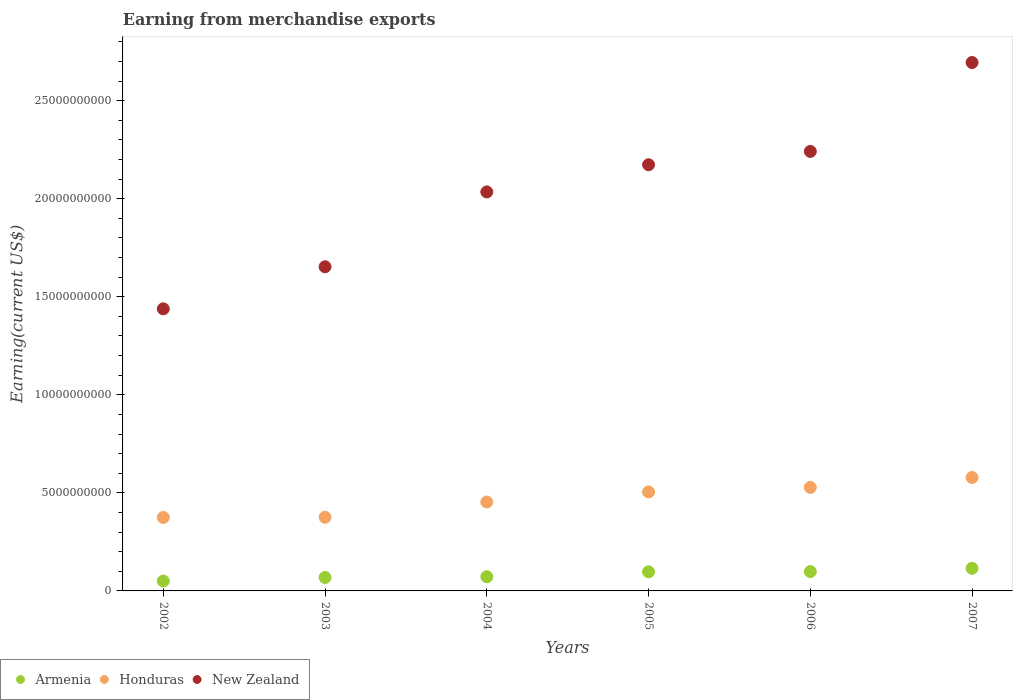Is the number of dotlines equal to the number of legend labels?
Provide a succinct answer. Yes. What is the amount earned from merchandise exports in Honduras in 2007?
Your answer should be very brief. 5.78e+09. Across all years, what is the maximum amount earned from merchandise exports in Honduras?
Ensure brevity in your answer.  5.78e+09. Across all years, what is the minimum amount earned from merchandise exports in New Zealand?
Your answer should be compact. 1.44e+1. What is the total amount earned from merchandise exports in Honduras in the graph?
Provide a succinct answer. 2.81e+1. What is the difference between the amount earned from merchandise exports in Honduras in 2003 and that in 2005?
Your answer should be very brief. -1.29e+09. What is the difference between the amount earned from merchandise exports in New Zealand in 2006 and the amount earned from merchandise exports in Honduras in 2005?
Your answer should be compact. 1.74e+1. What is the average amount earned from merchandise exports in Honduras per year?
Provide a short and direct response. 4.69e+09. In the year 2002, what is the difference between the amount earned from merchandise exports in New Zealand and amount earned from merchandise exports in Armenia?
Offer a very short reply. 1.39e+1. In how many years, is the amount earned from merchandise exports in Honduras greater than 21000000000 US$?
Provide a succinct answer. 0. What is the ratio of the amount earned from merchandise exports in Armenia in 2002 to that in 2003?
Make the answer very short. 0.74. What is the difference between the highest and the second highest amount earned from merchandise exports in Honduras?
Give a very brief answer. 5.07e+08. What is the difference between the highest and the lowest amount earned from merchandise exports in New Zealand?
Your response must be concise. 1.26e+1. Is the sum of the amount earned from merchandise exports in Honduras in 2002 and 2006 greater than the maximum amount earned from merchandise exports in Armenia across all years?
Your response must be concise. Yes. Is the amount earned from merchandise exports in New Zealand strictly greater than the amount earned from merchandise exports in Honduras over the years?
Keep it short and to the point. Yes. How many dotlines are there?
Your answer should be very brief. 3. What is the difference between two consecutive major ticks on the Y-axis?
Ensure brevity in your answer.  5.00e+09. Are the values on the major ticks of Y-axis written in scientific E-notation?
Your response must be concise. No. Does the graph contain any zero values?
Your answer should be compact. No. What is the title of the graph?
Keep it short and to the point. Earning from merchandise exports. Does "Europe(all income levels)" appear as one of the legend labels in the graph?
Offer a terse response. No. What is the label or title of the Y-axis?
Your answer should be compact. Earning(current US$). What is the Earning(current US$) of Armenia in 2002?
Offer a terse response. 5.05e+08. What is the Earning(current US$) in Honduras in 2002?
Your response must be concise. 3.74e+09. What is the Earning(current US$) in New Zealand in 2002?
Ensure brevity in your answer.  1.44e+1. What is the Earning(current US$) of Armenia in 2003?
Your answer should be compact. 6.86e+08. What is the Earning(current US$) in Honduras in 2003?
Your answer should be very brief. 3.75e+09. What is the Earning(current US$) of New Zealand in 2003?
Your answer should be very brief. 1.65e+1. What is the Earning(current US$) of Armenia in 2004?
Give a very brief answer. 7.23e+08. What is the Earning(current US$) of Honduras in 2004?
Your answer should be very brief. 4.53e+09. What is the Earning(current US$) of New Zealand in 2004?
Provide a succinct answer. 2.03e+1. What is the Earning(current US$) in Armenia in 2005?
Keep it short and to the point. 9.74e+08. What is the Earning(current US$) of Honduras in 2005?
Your response must be concise. 5.05e+09. What is the Earning(current US$) in New Zealand in 2005?
Keep it short and to the point. 2.17e+1. What is the Earning(current US$) of Armenia in 2006?
Your answer should be compact. 9.85e+08. What is the Earning(current US$) in Honduras in 2006?
Your answer should be compact. 5.28e+09. What is the Earning(current US$) of New Zealand in 2006?
Offer a terse response. 2.24e+1. What is the Earning(current US$) of Armenia in 2007?
Make the answer very short. 1.15e+09. What is the Earning(current US$) of Honduras in 2007?
Keep it short and to the point. 5.78e+09. What is the Earning(current US$) in New Zealand in 2007?
Your response must be concise. 2.69e+1. Across all years, what is the maximum Earning(current US$) in Armenia?
Make the answer very short. 1.15e+09. Across all years, what is the maximum Earning(current US$) of Honduras?
Provide a succinct answer. 5.78e+09. Across all years, what is the maximum Earning(current US$) of New Zealand?
Your response must be concise. 2.69e+1. Across all years, what is the minimum Earning(current US$) in Armenia?
Ensure brevity in your answer.  5.05e+08. Across all years, what is the minimum Earning(current US$) of Honduras?
Provide a succinct answer. 3.74e+09. Across all years, what is the minimum Earning(current US$) in New Zealand?
Give a very brief answer. 1.44e+1. What is the total Earning(current US$) in Armenia in the graph?
Keep it short and to the point. 5.02e+09. What is the total Earning(current US$) in Honduras in the graph?
Offer a terse response. 2.81e+1. What is the total Earning(current US$) of New Zealand in the graph?
Provide a short and direct response. 1.22e+11. What is the difference between the Earning(current US$) in Armenia in 2002 and that in 2003?
Your answer should be compact. -1.80e+08. What is the difference between the Earning(current US$) of Honduras in 2002 and that in 2003?
Your answer should be very brief. -9.14e+06. What is the difference between the Earning(current US$) in New Zealand in 2002 and that in 2003?
Your answer should be very brief. -2.14e+09. What is the difference between the Earning(current US$) of Armenia in 2002 and that in 2004?
Offer a very short reply. -2.18e+08. What is the difference between the Earning(current US$) of Honduras in 2002 and that in 2004?
Give a very brief answer. -7.89e+08. What is the difference between the Earning(current US$) in New Zealand in 2002 and that in 2004?
Provide a short and direct response. -5.96e+09. What is the difference between the Earning(current US$) of Armenia in 2002 and that in 2005?
Your response must be concise. -4.69e+08. What is the difference between the Earning(current US$) in Honduras in 2002 and that in 2005?
Provide a short and direct response. -1.30e+09. What is the difference between the Earning(current US$) of New Zealand in 2002 and that in 2005?
Offer a terse response. -7.35e+09. What is the difference between the Earning(current US$) in Armenia in 2002 and that in 2006?
Make the answer very short. -4.80e+08. What is the difference between the Earning(current US$) of Honduras in 2002 and that in 2006?
Keep it short and to the point. -1.53e+09. What is the difference between the Earning(current US$) of New Zealand in 2002 and that in 2006?
Offer a very short reply. -8.03e+09. What is the difference between the Earning(current US$) in Armenia in 2002 and that in 2007?
Keep it short and to the point. -6.47e+08. What is the difference between the Earning(current US$) in Honduras in 2002 and that in 2007?
Ensure brevity in your answer.  -2.04e+09. What is the difference between the Earning(current US$) of New Zealand in 2002 and that in 2007?
Give a very brief answer. -1.26e+1. What is the difference between the Earning(current US$) in Armenia in 2003 and that in 2004?
Ensure brevity in your answer.  -3.73e+07. What is the difference between the Earning(current US$) in Honduras in 2003 and that in 2004?
Your answer should be compact. -7.80e+08. What is the difference between the Earning(current US$) in New Zealand in 2003 and that in 2004?
Your answer should be very brief. -3.82e+09. What is the difference between the Earning(current US$) of Armenia in 2003 and that in 2005?
Offer a terse response. -2.88e+08. What is the difference between the Earning(current US$) in Honduras in 2003 and that in 2005?
Your answer should be compact. -1.29e+09. What is the difference between the Earning(current US$) of New Zealand in 2003 and that in 2005?
Give a very brief answer. -5.20e+09. What is the difference between the Earning(current US$) in Armenia in 2003 and that in 2006?
Make the answer very short. -3.00e+08. What is the difference between the Earning(current US$) in Honduras in 2003 and that in 2006?
Ensure brevity in your answer.  -1.52e+09. What is the difference between the Earning(current US$) in New Zealand in 2003 and that in 2006?
Provide a succinct answer. -5.88e+09. What is the difference between the Earning(current US$) in Armenia in 2003 and that in 2007?
Your answer should be compact. -4.67e+08. What is the difference between the Earning(current US$) of Honduras in 2003 and that in 2007?
Make the answer very short. -2.03e+09. What is the difference between the Earning(current US$) of New Zealand in 2003 and that in 2007?
Offer a very short reply. -1.04e+1. What is the difference between the Earning(current US$) in Armenia in 2004 and that in 2005?
Offer a very short reply. -2.51e+08. What is the difference between the Earning(current US$) in Honduras in 2004 and that in 2005?
Offer a very short reply. -5.14e+08. What is the difference between the Earning(current US$) in New Zealand in 2004 and that in 2005?
Provide a short and direct response. -1.39e+09. What is the difference between the Earning(current US$) in Armenia in 2004 and that in 2006?
Give a very brief answer. -2.62e+08. What is the difference between the Earning(current US$) in Honduras in 2004 and that in 2006?
Ensure brevity in your answer.  -7.43e+08. What is the difference between the Earning(current US$) of New Zealand in 2004 and that in 2006?
Your answer should be very brief. -2.07e+09. What is the difference between the Earning(current US$) in Armenia in 2004 and that in 2007?
Your answer should be very brief. -4.29e+08. What is the difference between the Earning(current US$) in Honduras in 2004 and that in 2007?
Your answer should be very brief. -1.25e+09. What is the difference between the Earning(current US$) of New Zealand in 2004 and that in 2007?
Your answer should be very brief. -6.60e+09. What is the difference between the Earning(current US$) of Armenia in 2005 and that in 2006?
Provide a short and direct response. -1.12e+07. What is the difference between the Earning(current US$) of Honduras in 2005 and that in 2006?
Ensure brevity in your answer.  -2.29e+08. What is the difference between the Earning(current US$) in New Zealand in 2005 and that in 2006?
Offer a terse response. -6.79e+08. What is the difference between the Earning(current US$) in Armenia in 2005 and that in 2007?
Give a very brief answer. -1.78e+08. What is the difference between the Earning(current US$) of Honduras in 2005 and that in 2007?
Provide a short and direct response. -7.36e+08. What is the difference between the Earning(current US$) of New Zealand in 2005 and that in 2007?
Give a very brief answer. -5.21e+09. What is the difference between the Earning(current US$) of Armenia in 2006 and that in 2007?
Your answer should be very brief. -1.67e+08. What is the difference between the Earning(current US$) of Honduras in 2006 and that in 2007?
Offer a very short reply. -5.07e+08. What is the difference between the Earning(current US$) of New Zealand in 2006 and that in 2007?
Your answer should be compact. -4.53e+09. What is the difference between the Earning(current US$) in Armenia in 2002 and the Earning(current US$) in Honduras in 2003?
Your response must be concise. -3.25e+09. What is the difference between the Earning(current US$) in Armenia in 2002 and the Earning(current US$) in New Zealand in 2003?
Ensure brevity in your answer.  -1.60e+1. What is the difference between the Earning(current US$) of Honduras in 2002 and the Earning(current US$) of New Zealand in 2003?
Offer a terse response. -1.28e+1. What is the difference between the Earning(current US$) in Armenia in 2002 and the Earning(current US$) in Honduras in 2004?
Your answer should be compact. -4.03e+09. What is the difference between the Earning(current US$) in Armenia in 2002 and the Earning(current US$) in New Zealand in 2004?
Make the answer very short. -1.98e+1. What is the difference between the Earning(current US$) of Honduras in 2002 and the Earning(current US$) of New Zealand in 2004?
Your answer should be compact. -1.66e+1. What is the difference between the Earning(current US$) in Armenia in 2002 and the Earning(current US$) in Honduras in 2005?
Keep it short and to the point. -4.54e+09. What is the difference between the Earning(current US$) in Armenia in 2002 and the Earning(current US$) in New Zealand in 2005?
Provide a succinct answer. -2.12e+1. What is the difference between the Earning(current US$) of Honduras in 2002 and the Earning(current US$) of New Zealand in 2005?
Offer a very short reply. -1.80e+1. What is the difference between the Earning(current US$) in Armenia in 2002 and the Earning(current US$) in Honduras in 2006?
Provide a short and direct response. -4.77e+09. What is the difference between the Earning(current US$) in Armenia in 2002 and the Earning(current US$) in New Zealand in 2006?
Offer a very short reply. -2.19e+1. What is the difference between the Earning(current US$) of Honduras in 2002 and the Earning(current US$) of New Zealand in 2006?
Provide a succinct answer. -1.87e+1. What is the difference between the Earning(current US$) in Armenia in 2002 and the Earning(current US$) in Honduras in 2007?
Your answer should be compact. -5.28e+09. What is the difference between the Earning(current US$) of Armenia in 2002 and the Earning(current US$) of New Zealand in 2007?
Your answer should be very brief. -2.64e+1. What is the difference between the Earning(current US$) in Honduras in 2002 and the Earning(current US$) in New Zealand in 2007?
Your response must be concise. -2.32e+1. What is the difference between the Earning(current US$) in Armenia in 2003 and the Earning(current US$) in Honduras in 2004?
Your answer should be very brief. -3.85e+09. What is the difference between the Earning(current US$) of Armenia in 2003 and the Earning(current US$) of New Zealand in 2004?
Keep it short and to the point. -1.97e+1. What is the difference between the Earning(current US$) in Honduras in 2003 and the Earning(current US$) in New Zealand in 2004?
Your response must be concise. -1.66e+1. What is the difference between the Earning(current US$) in Armenia in 2003 and the Earning(current US$) in Honduras in 2005?
Keep it short and to the point. -4.36e+09. What is the difference between the Earning(current US$) of Armenia in 2003 and the Earning(current US$) of New Zealand in 2005?
Your answer should be very brief. -2.10e+1. What is the difference between the Earning(current US$) of Honduras in 2003 and the Earning(current US$) of New Zealand in 2005?
Your answer should be very brief. -1.80e+1. What is the difference between the Earning(current US$) in Armenia in 2003 and the Earning(current US$) in Honduras in 2006?
Your answer should be compact. -4.59e+09. What is the difference between the Earning(current US$) of Armenia in 2003 and the Earning(current US$) of New Zealand in 2006?
Your response must be concise. -2.17e+1. What is the difference between the Earning(current US$) in Honduras in 2003 and the Earning(current US$) in New Zealand in 2006?
Your answer should be compact. -1.87e+1. What is the difference between the Earning(current US$) in Armenia in 2003 and the Earning(current US$) in Honduras in 2007?
Provide a succinct answer. -5.10e+09. What is the difference between the Earning(current US$) in Armenia in 2003 and the Earning(current US$) in New Zealand in 2007?
Your response must be concise. -2.63e+1. What is the difference between the Earning(current US$) of Honduras in 2003 and the Earning(current US$) of New Zealand in 2007?
Your answer should be very brief. -2.32e+1. What is the difference between the Earning(current US$) in Armenia in 2004 and the Earning(current US$) in Honduras in 2005?
Your response must be concise. -4.33e+09. What is the difference between the Earning(current US$) of Armenia in 2004 and the Earning(current US$) of New Zealand in 2005?
Your answer should be very brief. -2.10e+1. What is the difference between the Earning(current US$) in Honduras in 2004 and the Earning(current US$) in New Zealand in 2005?
Ensure brevity in your answer.  -1.72e+1. What is the difference between the Earning(current US$) of Armenia in 2004 and the Earning(current US$) of Honduras in 2006?
Ensure brevity in your answer.  -4.55e+09. What is the difference between the Earning(current US$) in Armenia in 2004 and the Earning(current US$) in New Zealand in 2006?
Your response must be concise. -2.17e+1. What is the difference between the Earning(current US$) in Honduras in 2004 and the Earning(current US$) in New Zealand in 2006?
Ensure brevity in your answer.  -1.79e+1. What is the difference between the Earning(current US$) of Armenia in 2004 and the Earning(current US$) of Honduras in 2007?
Your answer should be compact. -5.06e+09. What is the difference between the Earning(current US$) of Armenia in 2004 and the Earning(current US$) of New Zealand in 2007?
Provide a short and direct response. -2.62e+1. What is the difference between the Earning(current US$) in Honduras in 2004 and the Earning(current US$) in New Zealand in 2007?
Give a very brief answer. -2.24e+1. What is the difference between the Earning(current US$) in Armenia in 2005 and the Earning(current US$) in Honduras in 2006?
Make the answer very short. -4.30e+09. What is the difference between the Earning(current US$) in Armenia in 2005 and the Earning(current US$) in New Zealand in 2006?
Your answer should be very brief. -2.14e+1. What is the difference between the Earning(current US$) of Honduras in 2005 and the Earning(current US$) of New Zealand in 2006?
Provide a succinct answer. -1.74e+1. What is the difference between the Earning(current US$) in Armenia in 2005 and the Earning(current US$) in Honduras in 2007?
Keep it short and to the point. -4.81e+09. What is the difference between the Earning(current US$) of Armenia in 2005 and the Earning(current US$) of New Zealand in 2007?
Your answer should be very brief. -2.60e+1. What is the difference between the Earning(current US$) in Honduras in 2005 and the Earning(current US$) in New Zealand in 2007?
Your answer should be very brief. -2.19e+1. What is the difference between the Earning(current US$) in Armenia in 2006 and the Earning(current US$) in Honduras in 2007?
Provide a succinct answer. -4.80e+09. What is the difference between the Earning(current US$) of Armenia in 2006 and the Earning(current US$) of New Zealand in 2007?
Offer a very short reply. -2.60e+1. What is the difference between the Earning(current US$) of Honduras in 2006 and the Earning(current US$) of New Zealand in 2007?
Your response must be concise. -2.17e+1. What is the average Earning(current US$) in Armenia per year?
Your answer should be compact. 8.37e+08. What is the average Earning(current US$) of Honduras per year?
Provide a short and direct response. 4.69e+09. What is the average Earning(current US$) of New Zealand per year?
Keep it short and to the point. 2.04e+1. In the year 2002, what is the difference between the Earning(current US$) of Armenia and Earning(current US$) of Honduras?
Your response must be concise. -3.24e+09. In the year 2002, what is the difference between the Earning(current US$) in Armenia and Earning(current US$) in New Zealand?
Offer a very short reply. -1.39e+1. In the year 2002, what is the difference between the Earning(current US$) in Honduras and Earning(current US$) in New Zealand?
Provide a succinct answer. -1.06e+1. In the year 2003, what is the difference between the Earning(current US$) in Armenia and Earning(current US$) in Honduras?
Provide a succinct answer. -3.07e+09. In the year 2003, what is the difference between the Earning(current US$) in Armenia and Earning(current US$) in New Zealand?
Offer a very short reply. -1.58e+1. In the year 2003, what is the difference between the Earning(current US$) in Honduras and Earning(current US$) in New Zealand?
Ensure brevity in your answer.  -1.28e+1. In the year 2004, what is the difference between the Earning(current US$) of Armenia and Earning(current US$) of Honduras?
Ensure brevity in your answer.  -3.81e+09. In the year 2004, what is the difference between the Earning(current US$) of Armenia and Earning(current US$) of New Zealand?
Provide a short and direct response. -1.96e+1. In the year 2004, what is the difference between the Earning(current US$) in Honduras and Earning(current US$) in New Zealand?
Give a very brief answer. -1.58e+1. In the year 2005, what is the difference between the Earning(current US$) of Armenia and Earning(current US$) of Honduras?
Provide a succinct answer. -4.07e+09. In the year 2005, what is the difference between the Earning(current US$) of Armenia and Earning(current US$) of New Zealand?
Your answer should be very brief. -2.08e+1. In the year 2005, what is the difference between the Earning(current US$) of Honduras and Earning(current US$) of New Zealand?
Your answer should be compact. -1.67e+1. In the year 2006, what is the difference between the Earning(current US$) of Armenia and Earning(current US$) of Honduras?
Provide a succinct answer. -4.29e+09. In the year 2006, what is the difference between the Earning(current US$) of Armenia and Earning(current US$) of New Zealand?
Your answer should be compact. -2.14e+1. In the year 2006, what is the difference between the Earning(current US$) in Honduras and Earning(current US$) in New Zealand?
Ensure brevity in your answer.  -1.71e+1. In the year 2007, what is the difference between the Earning(current US$) of Armenia and Earning(current US$) of Honduras?
Your response must be concise. -4.63e+09. In the year 2007, what is the difference between the Earning(current US$) in Armenia and Earning(current US$) in New Zealand?
Offer a terse response. -2.58e+1. In the year 2007, what is the difference between the Earning(current US$) in Honduras and Earning(current US$) in New Zealand?
Provide a short and direct response. -2.12e+1. What is the ratio of the Earning(current US$) of Armenia in 2002 to that in 2003?
Your response must be concise. 0.74. What is the ratio of the Earning(current US$) in New Zealand in 2002 to that in 2003?
Your answer should be compact. 0.87. What is the ratio of the Earning(current US$) in Armenia in 2002 to that in 2004?
Your answer should be compact. 0.7. What is the ratio of the Earning(current US$) in Honduras in 2002 to that in 2004?
Ensure brevity in your answer.  0.83. What is the ratio of the Earning(current US$) of New Zealand in 2002 to that in 2004?
Make the answer very short. 0.71. What is the ratio of the Earning(current US$) of Armenia in 2002 to that in 2005?
Your response must be concise. 0.52. What is the ratio of the Earning(current US$) of Honduras in 2002 to that in 2005?
Ensure brevity in your answer.  0.74. What is the ratio of the Earning(current US$) of New Zealand in 2002 to that in 2005?
Offer a very short reply. 0.66. What is the ratio of the Earning(current US$) in Armenia in 2002 to that in 2006?
Provide a succinct answer. 0.51. What is the ratio of the Earning(current US$) in Honduras in 2002 to that in 2006?
Your response must be concise. 0.71. What is the ratio of the Earning(current US$) of New Zealand in 2002 to that in 2006?
Make the answer very short. 0.64. What is the ratio of the Earning(current US$) in Armenia in 2002 to that in 2007?
Your response must be concise. 0.44. What is the ratio of the Earning(current US$) of Honduras in 2002 to that in 2007?
Make the answer very short. 0.65. What is the ratio of the Earning(current US$) of New Zealand in 2002 to that in 2007?
Make the answer very short. 0.53. What is the ratio of the Earning(current US$) of Armenia in 2003 to that in 2004?
Ensure brevity in your answer.  0.95. What is the ratio of the Earning(current US$) in Honduras in 2003 to that in 2004?
Offer a very short reply. 0.83. What is the ratio of the Earning(current US$) of New Zealand in 2003 to that in 2004?
Keep it short and to the point. 0.81. What is the ratio of the Earning(current US$) in Armenia in 2003 to that in 2005?
Provide a short and direct response. 0.7. What is the ratio of the Earning(current US$) of Honduras in 2003 to that in 2005?
Keep it short and to the point. 0.74. What is the ratio of the Earning(current US$) in New Zealand in 2003 to that in 2005?
Offer a very short reply. 0.76. What is the ratio of the Earning(current US$) in Armenia in 2003 to that in 2006?
Give a very brief answer. 0.7. What is the ratio of the Earning(current US$) in Honduras in 2003 to that in 2006?
Keep it short and to the point. 0.71. What is the ratio of the Earning(current US$) in New Zealand in 2003 to that in 2006?
Make the answer very short. 0.74. What is the ratio of the Earning(current US$) in Armenia in 2003 to that in 2007?
Your answer should be compact. 0.59. What is the ratio of the Earning(current US$) in Honduras in 2003 to that in 2007?
Provide a short and direct response. 0.65. What is the ratio of the Earning(current US$) in New Zealand in 2003 to that in 2007?
Offer a very short reply. 0.61. What is the ratio of the Earning(current US$) in Armenia in 2004 to that in 2005?
Your answer should be compact. 0.74. What is the ratio of the Earning(current US$) in Honduras in 2004 to that in 2005?
Your response must be concise. 0.9. What is the ratio of the Earning(current US$) in New Zealand in 2004 to that in 2005?
Provide a succinct answer. 0.94. What is the ratio of the Earning(current US$) of Armenia in 2004 to that in 2006?
Give a very brief answer. 0.73. What is the ratio of the Earning(current US$) in Honduras in 2004 to that in 2006?
Your response must be concise. 0.86. What is the ratio of the Earning(current US$) of New Zealand in 2004 to that in 2006?
Keep it short and to the point. 0.91. What is the ratio of the Earning(current US$) in Armenia in 2004 to that in 2007?
Keep it short and to the point. 0.63. What is the ratio of the Earning(current US$) in Honduras in 2004 to that in 2007?
Your answer should be very brief. 0.78. What is the ratio of the Earning(current US$) of New Zealand in 2004 to that in 2007?
Provide a succinct answer. 0.76. What is the ratio of the Earning(current US$) of Armenia in 2005 to that in 2006?
Provide a short and direct response. 0.99. What is the ratio of the Earning(current US$) in Honduras in 2005 to that in 2006?
Offer a terse response. 0.96. What is the ratio of the Earning(current US$) in New Zealand in 2005 to that in 2006?
Offer a terse response. 0.97. What is the ratio of the Earning(current US$) in Armenia in 2005 to that in 2007?
Give a very brief answer. 0.85. What is the ratio of the Earning(current US$) of Honduras in 2005 to that in 2007?
Ensure brevity in your answer.  0.87. What is the ratio of the Earning(current US$) in New Zealand in 2005 to that in 2007?
Provide a succinct answer. 0.81. What is the ratio of the Earning(current US$) in Armenia in 2006 to that in 2007?
Your answer should be compact. 0.85. What is the ratio of the Earning(current US$) in Honduras in 2006 to that in 2007?
Provide a succinct answer. 0.91. What is the ratio of the Earning(current US$) of New Zealand in 2006 to that in 2007?
Your answer should be very brief. 0.83. What is the difference between the highest and the second highest Earning(current US$) in Armenia?
Give a very brief answer. 1.67e+08. What is the difference between the highest and the second highest Earning(current US$) of Honduras?
Keep it short and to the point. 5.07e+08. What is the difference between the highest and the second highest Earning(current US$) in New Zealand?
Your answer should be very brief. 4.53e+09. What is the difference between the highest and the lowest Earning(current US$) in Armenia?
Offer a very short reply. 6.47e+08. What is the difference between the highest and the lowest Earning(current US$) in Honduras?
Offer a terse response. 2.04e+09. What is the difference between the highest and the lowest Earning(current US$) in New Zealand?
Give a very brief answer. 1.26e+1. 